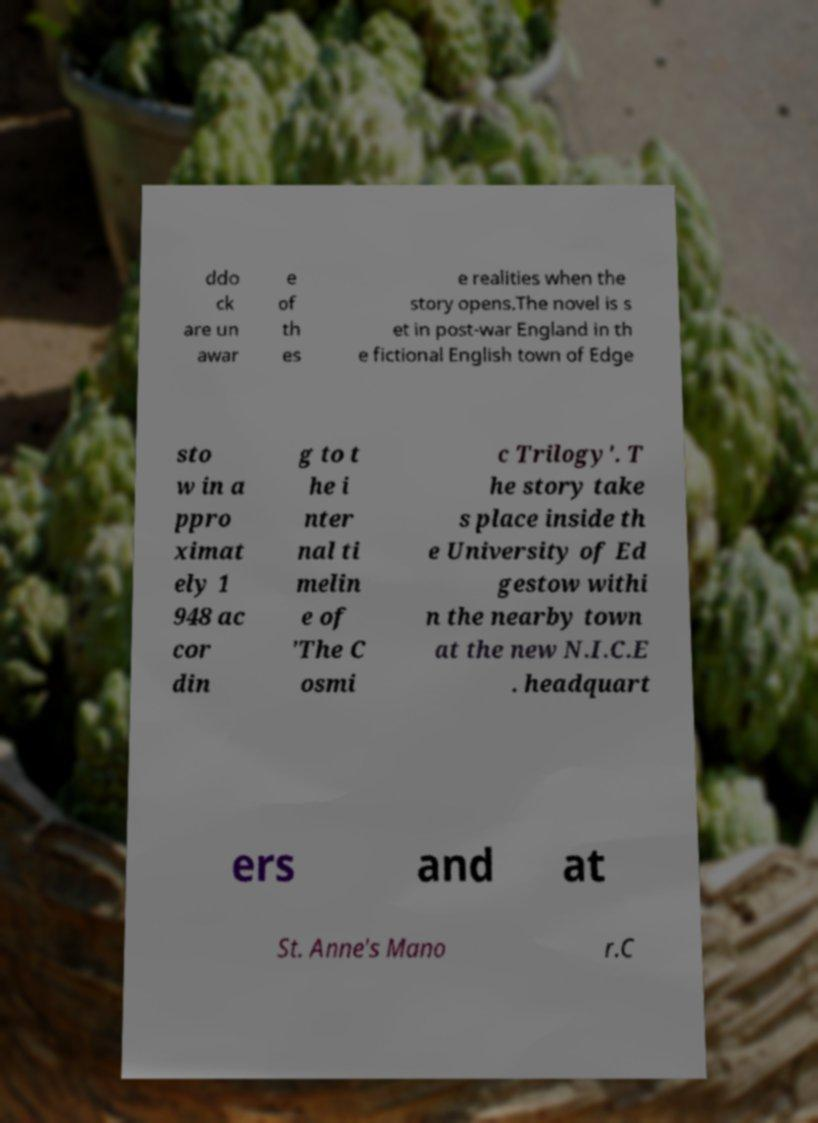Can you read and provide the text displayed in the image?This photo seems to have some interesting text. Can you extract and type it out for me? ddo ck are un awar e of th es e realities when the story opens.The novel is s et in post-war England in th e fictional English town of Edge sto w in a ppro ximat ely 1 948 ac cor din g to t he i nter nal ti melin e of 'The C osmi c Trilogy'. T he story take s place inside th e University of Ed gestow withi n the nearby town at the new N.I.C.E . headquart ers and at St. Anne's Mano r.C 